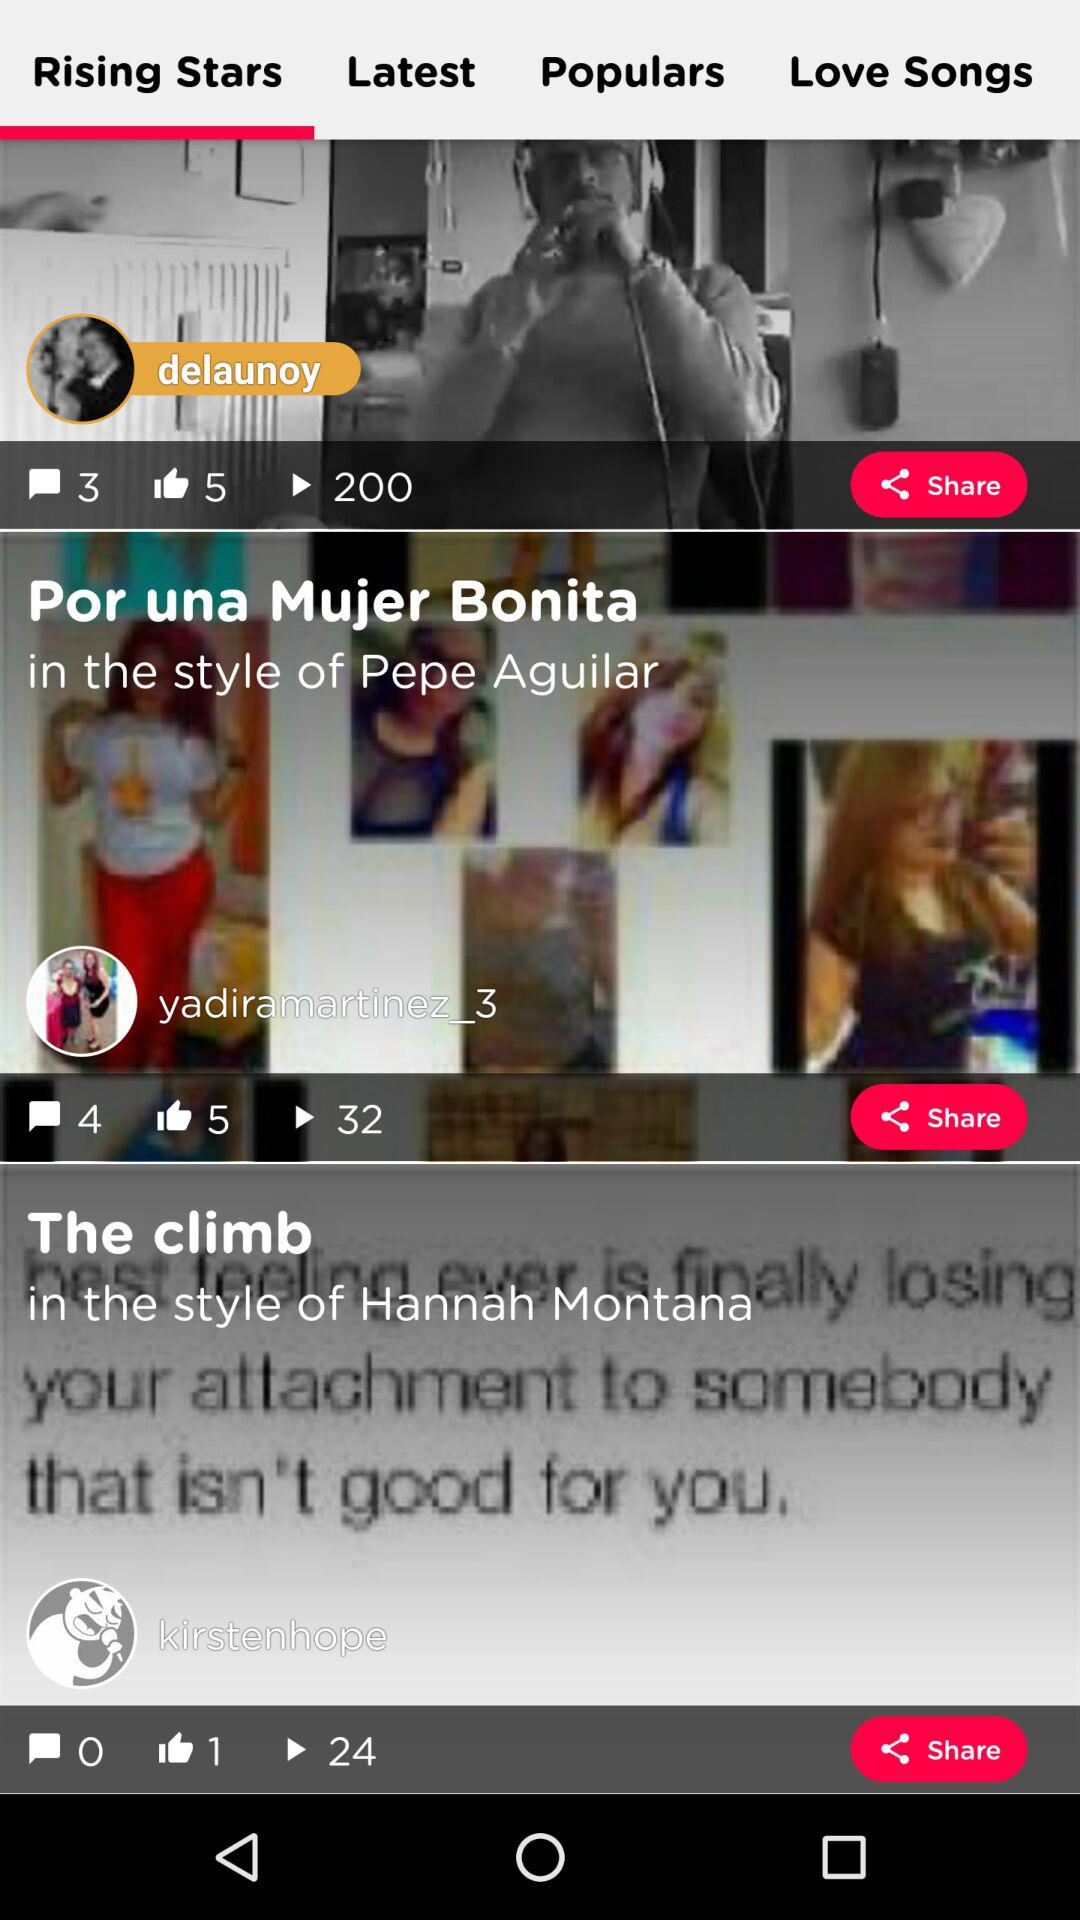How many plays in total are of Delaunoy's video? There are a total of 200 plays of Delaunoy's video. 